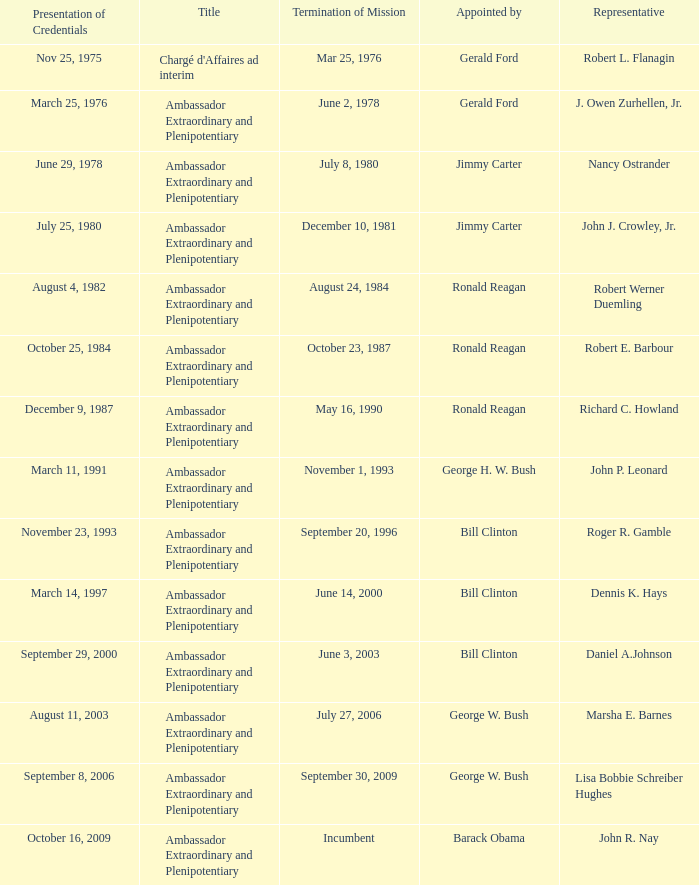Who appointed the representative that had a Presentation of Credentials on March 25, 1976? Gerald Ford. 